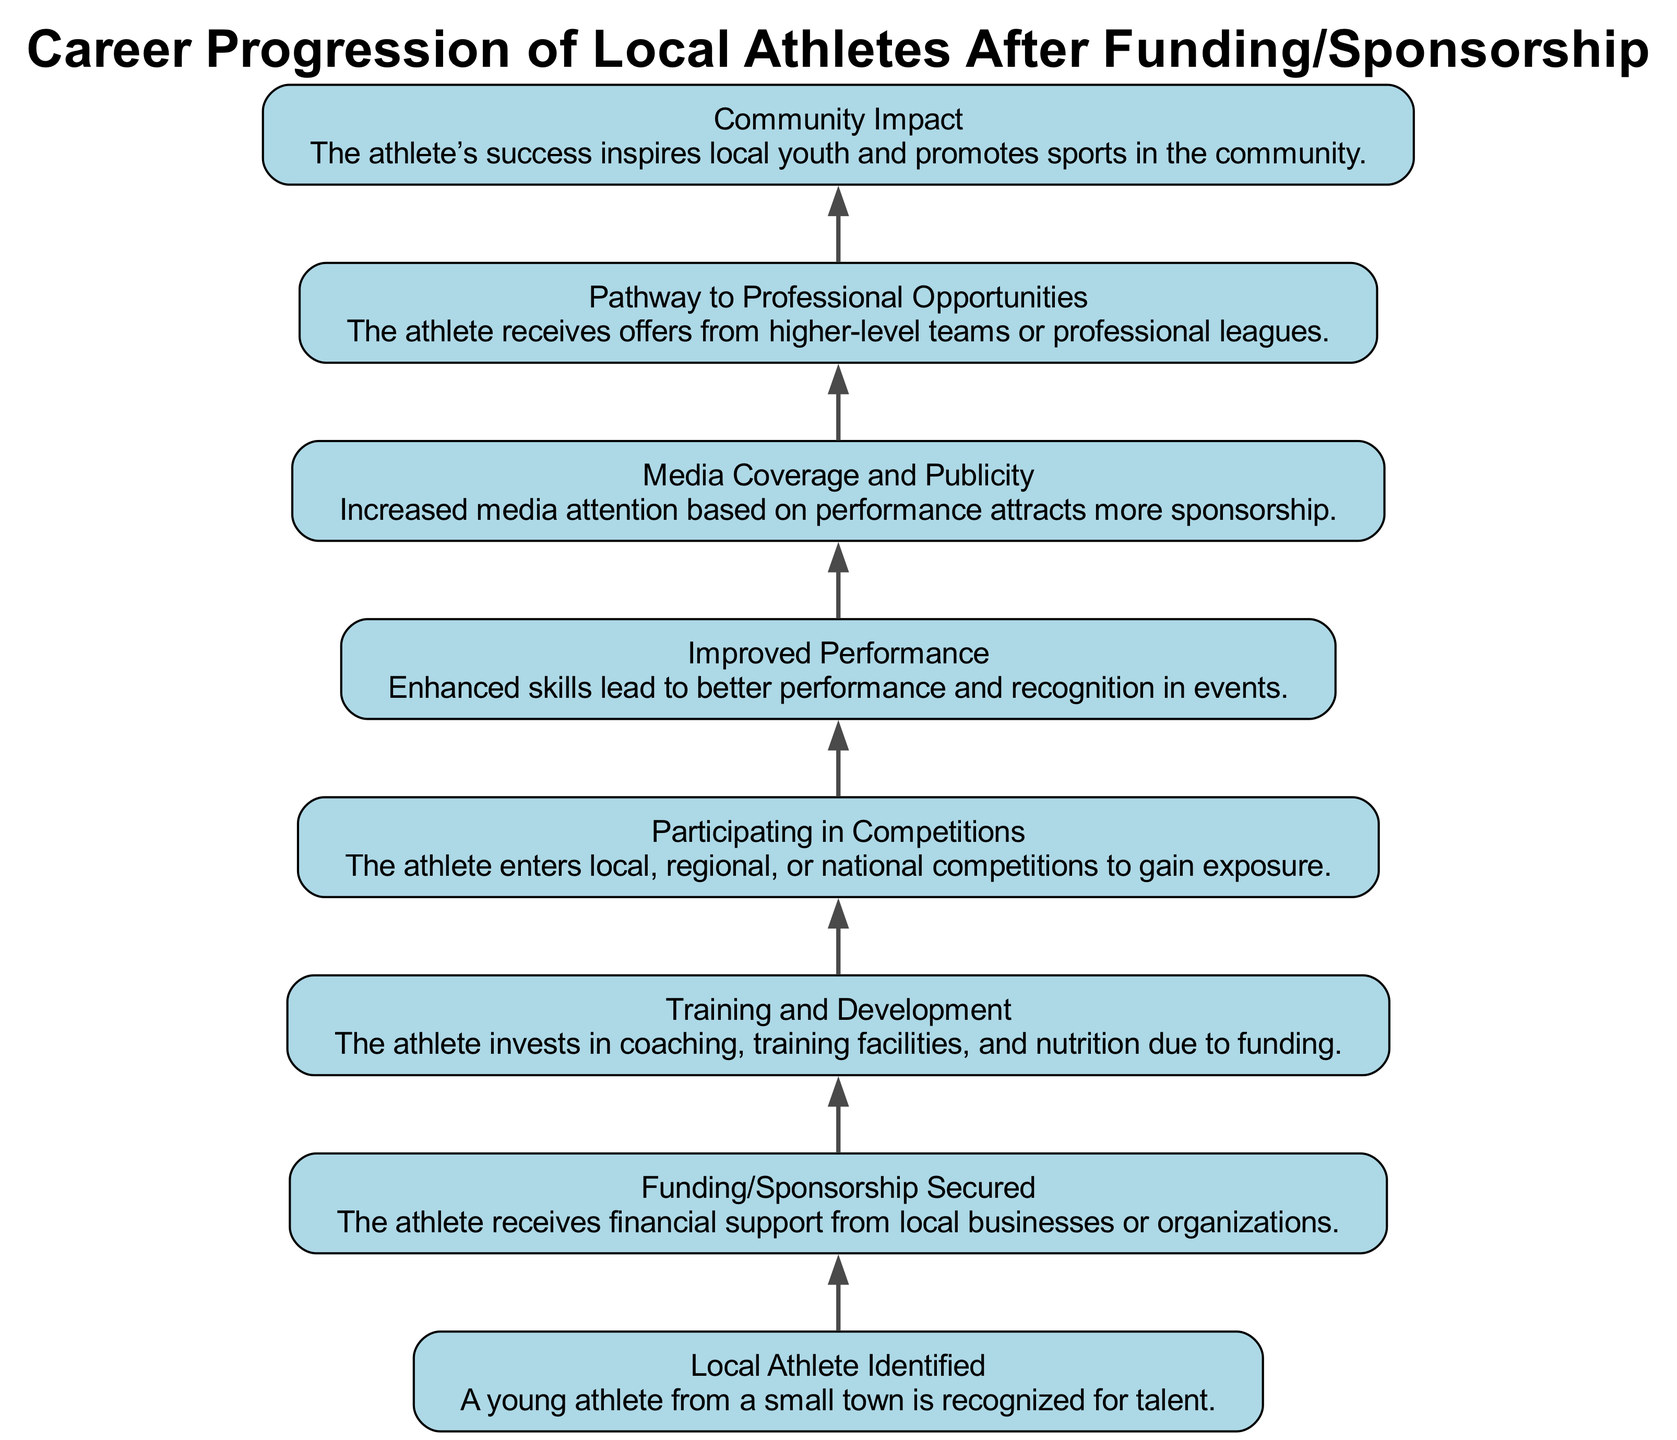What is the first stage of the career progression? The diagram indicates that the first stage is "Local Athlete Identified," which is the starting point in the career progression narrative.
Answer: Local Athlete Identified How many elements are in the diagram? By counting the nodes in the diagram, we can see that there are a total of eight elements (nodes) representing different stages of career progression.
Answer: Eight What follows "Funding/Sponsorship Secured"? In the flow chart, "Training and Development" directly follows the node "Funding/Sponsorship Secured," indicating the subsequent step in the process after securing financial support.
Answer: Training and Development Which element indicates community involvement? The diagram points to "Community Impact," which signifies the stage where the athlete's success starts to influence and inspire local youth as well as promote sports in the community.
Answer: Community Impact What is the relationship between "Improved Performance" and "Media Coverage and Publicity"? "Improved Performance" leads to "Media Coverage and Publicity," showing a direct connection where better performance results in increased media attention and recognition.
Answer: Improved Performance → Media Coverage and Publicity What is the final stage of the athlete's career progression? According to the diagram, the last indicated stage is "Community Impact," which signifies the culmination of the athlete’s journey and its influence on the community.
Answer: Community Impact How does "Participating in Competitions" relate to "Pathway to Professional Opportunities"? The flow chart shows that after "Participating in Competitions," the athlete progresses to "Pathway to Professional Opportunities," illustrating that competition participation is a critical step towards receiving professional offers.
Answer: Participating in Competitions → Pathway to Professional Opportunities What might be a possible outcome of securing funding? The outcome of securing funding is depicted as "Training and Development," which indicates that financial support allows the athlete to enhance their skills through better coaching and facilities.
Answer: Training and Development 